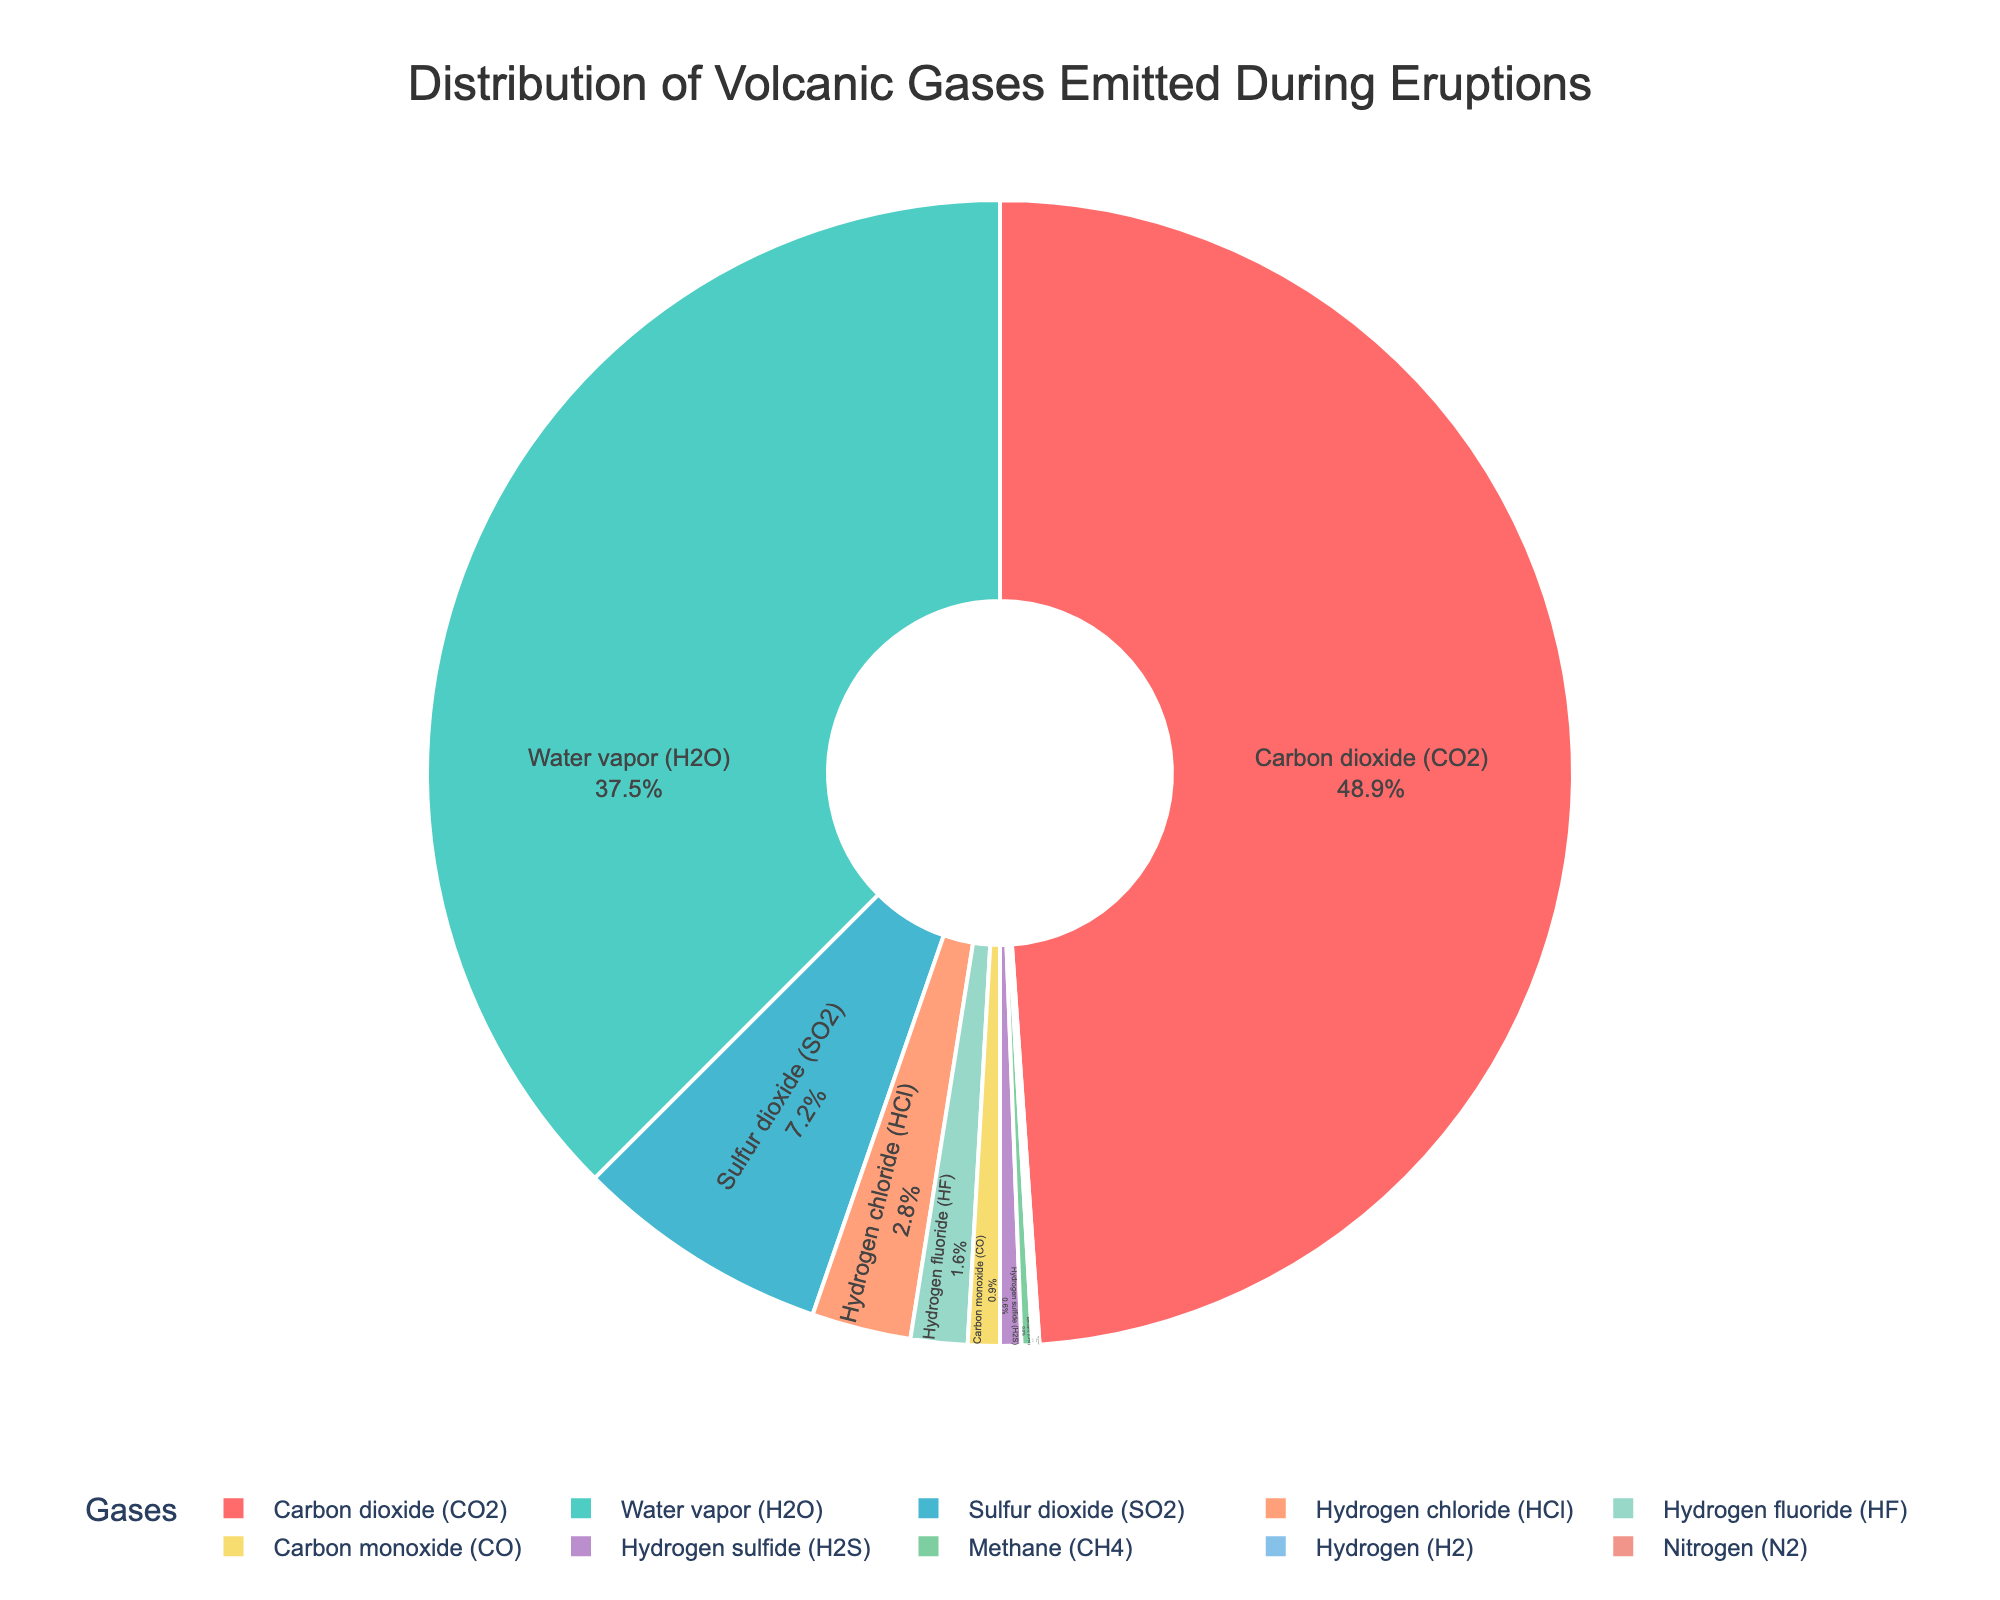What is the largest percentage of volcanic gas emitted during eruptions? The pie chart shows various gases and their percentage values. The largest segment corresponds to Carbon dioxide (CO2) at 48.9%.
Answer: 48.9% Which gas has the second-highest emission percentage? By observing the pie chart, the second largest segment corresponds to Water vapor (H2O) at 37.5%.
Answer: Water vapor (H2O) at 37.5% What is the combined percentage of Carbon dioxide (CO2) and Water vapor (H2O)? Adding the percentages of Carbon dioxide (CO2) and Water vapor (H2O) gives 48.9% + 37.5% = 86.4%.
Answer: 86.4% How much more significant is the percentage of Carbon dioxide (CO2) compared to Sulfur dioxide (SO2)? Subtract the percentage of Sulfur dioxide (SO2) from Carbon dioxide (CO2): 48.9% - 7.2% = 41.7%.
Answer: 41.7% What is the total percentage of gases other than CO2, H2O, and SO2? Summing the percentages of the remaining gases: HCl (2.8%) + HF (1.6%) + CO (0.9%) + H2S (0.6%) + CH4 (0.3%) + H2 (0.1%) + N2 (0.1%) = 6.4%.
Answer: 6.4% Which gas has the smallest emission percentage according to the chart? The pie chart shows that Hydrogen (H2) and Nitrogen (N2) each have the smallest percentage at 0.1%.
Answer: Hydrogen (H2) and Nitrogen (N2) at 0.1% Are the emissions of Carbon monoxide (CO) and Hydrogen sulfide (H2S) combined greater than that of Hydrogen fluoride (HF)? Adding the percentages of CO and H2S: 0.9% + 0.6% = 1.5%, which is less than the percentage of HF at 1.6%.
Answer: No What is the visual attribute of the gas with 2.8% emission in the pie chart? The gas with 2.8% emission is Hydrogen chloride (HCl), and it is represented by one of the distinct color segments in the chart.
Answer: Hydrogen chloride (HCl) at 2.8% How does the emission of Hydrogen chloride (HCl) compare to Methane (CH4)? The percentage of HCl is 2.8%, while that of CH4 is 0.3%, making HCl's emissions higher by 2.5%.
Answer: HCl is higher by 2.5% Which segment is represented with blue color, and what is its percentage? Observing the pie chart, the segment with a shade of blue corresponds to Water vapor (H2O), which has a percentage of 37.5%.
Answer: Water vapor (H2O) at 37.5% 